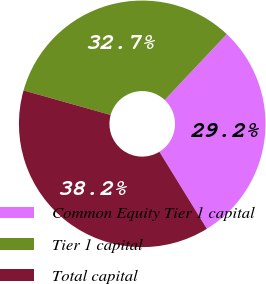Convert chart to OTSL. <chart><loc_0><loc_0><loc_500><loc_500><pie_chart><fcel>Common Equity Tier 1 capital<fcel>Tier 1 capital<fcel>Total capital<nl><fcel>29.18%<fcel>32.67%<fcel>38.16%<nl></chart> 